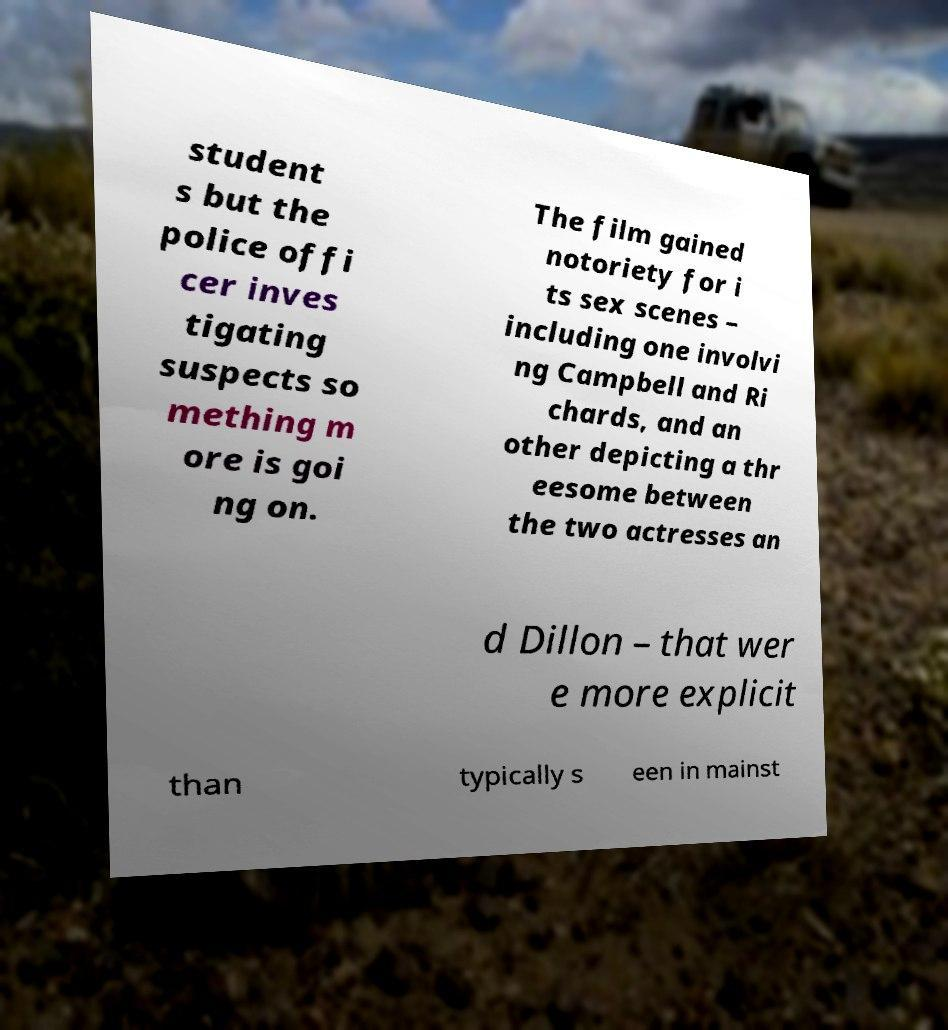Could you extract and type out the text from this image? student s but the police offi cer inves tigating suspects so mething m ore is goi ng on. The film gained notoriety for i ts sex scenes – including one involvi ng Campbell and Ri chards, and an other depicting a thr eesome between the two actresses an d Dillon – that wer e more explicit than typically s een in mainst 